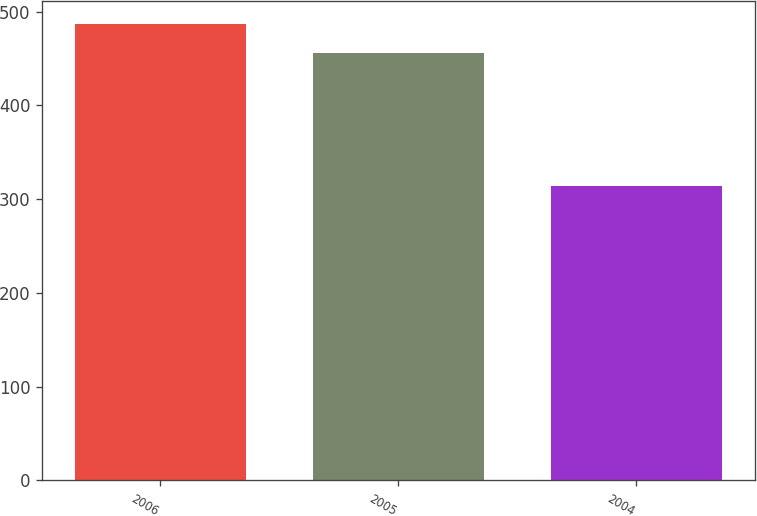Convert chart. <chart><loc_0><loc_0><loc_500><loc_500><bar_chart><fcel>2006<fcel>2005<fcel>2004<nl><fcel>487<fcel>456<fcel>314<nl></chart> 